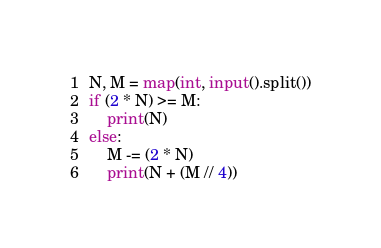<code> <loc_0><loc_0><loc_500><loc_500><_Python_>N, M = map(int, input().split())
if (2 * N) >= M:
    print(N)
else:
    M -= (2 * N)
    print(N + (M // 4))
</code> 